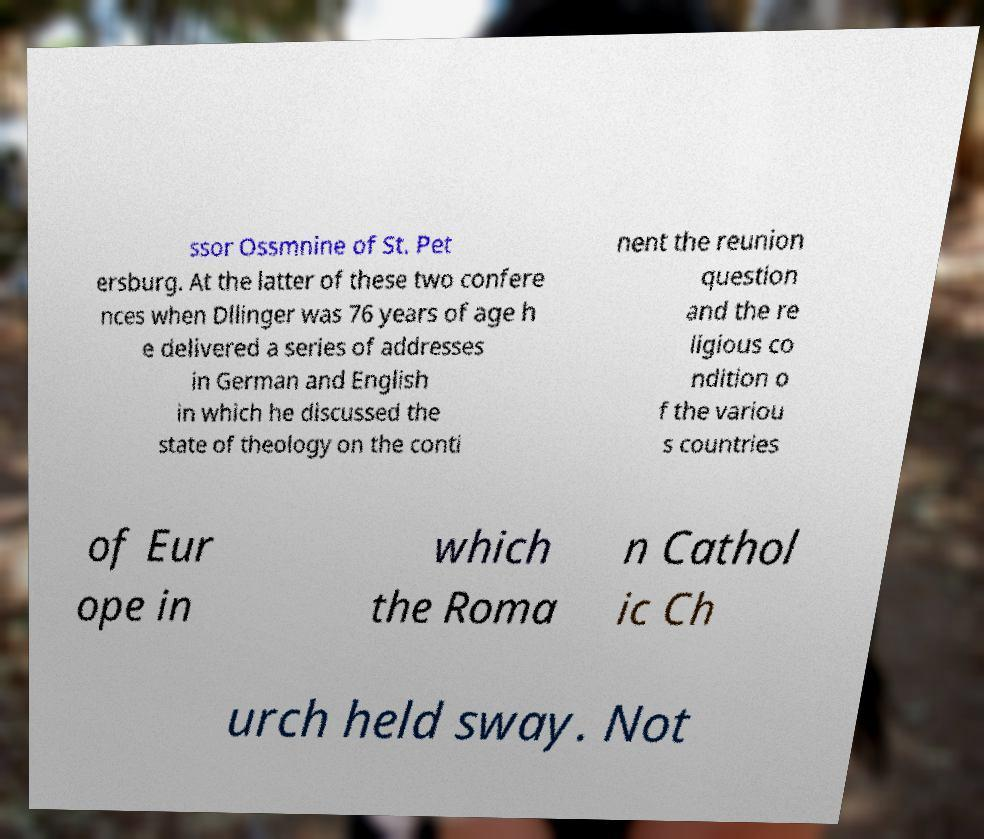Can you read and provide the text displayed in the image?This photo seems to have some interesting text. Can you extract and type it out for me? ssor Ossmnine of St. Pet ersburg. At the latter of these two confere nces when Dllinger was 76 years of age h e delivered a series of addresses in German and English in which he discussed the state of theology on the conti nent the reunion question and the re ligious co ndition o f the variou s countries of Eur ope in which the Roma n Cathol ic Ch urch held sway. Not 